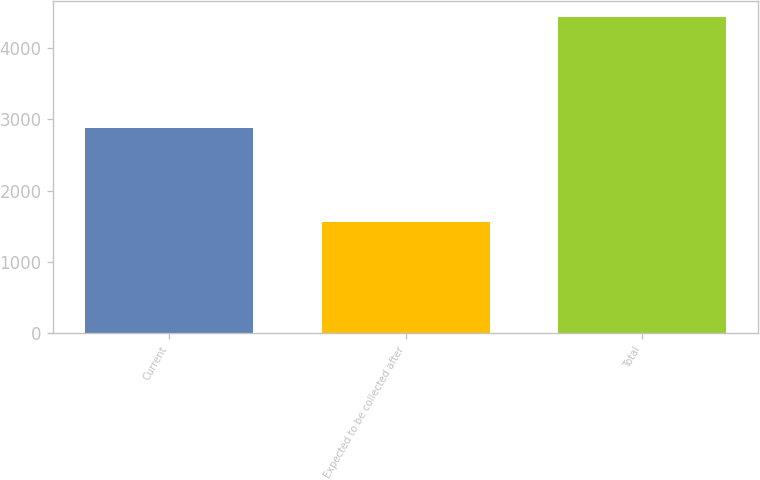Convert chart. <chart><loc_0><loc_0><loc_500><loc_500><bar_chart><fcel>Current<fcel>Expected to be collected after<fcel>Total<nl><fcel>2876<fcel>1564<fcel>4440<nl></chart> 